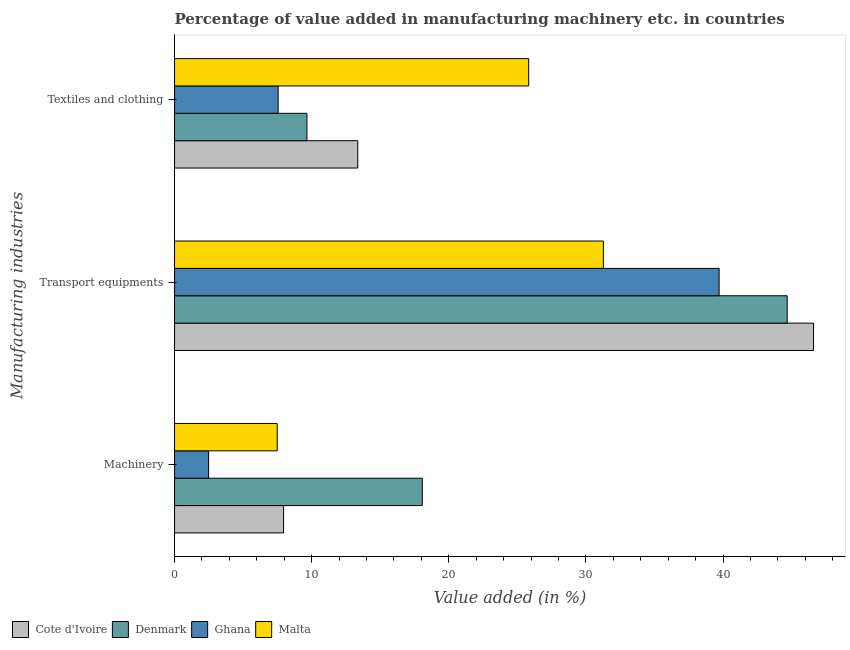How many different coloured bars are there?
Give a very brief answer. 4. How many bars are there on the 2nd tick from the top?
Give a very brief answer. 4. What is the label of the 2nd group of bars from the top?
Provide a short and direct response. Transport equipments. What is the value added in manufacturing machinery in Malta?
Offer a very short reply. 7.49. Across all countries, what is the maximum value added in manufacturing textile and clothing?
Provide a short and direct response. 25.83. Across all countries, what is the minimum value added in manufacturing textile and clothing?
Give a very brief answer. 7.55. In which country was the value added in manufacturing machinery maximum?
Provide a succinct answer. Denmark. In which country was the value added in manufacturing textile and clothing minimum?
Keep it short and to the point. Ghana. What is the total value added in manufacturing textile and clothing in the graph?
Your answer should be compact. 56.4. What is the difference between the value added in manufacturing textile and clothing in Malta and that in Cote d'Ivoire?
Ensure brevity in your answer.  12.47. What is the difference between the value added in manufacturing machinery in Denmark and the value added in manufacturing textile and clothing in Ghana?
Offer a terse response. 10.51. What is the average value added in manufacturing textile and clothing per country?
Provide a short and direct response. 14.1. What is the difference between the value added in manufacturing transport equipments and value added in manufacturing machinery in Malta?
Make the answer very short. 23.79. In how many countries, is the value added in manufacturing machinery greater than 14 %?
Your answer should be very brief. 1. What is the ratio of the value added in manufacturing textile and clothing in Malta to that in Cote d'Ivoire?
Your answer should be very brief. 1.93. Is the difference between the value added in manufacturing transport equipments in Malta and Ghana greater than the difference between the value added in manufacturing machinery in Malta and Ghana?
Give a very brief answer. No. What is the difference between the highest and the second highest value added in manufacturing machinery?
Give a very brief answer. 10.12. What is the difference between the highest and the lowest value added in manufacturing textile and clothing?
Your answer should be compact. 18.27. Is the sum of the value added in manufacturing machinery in Malta and Denmark greater than the maximum value added in manufacturing transport equipments across all countries?
Your answer should be very brief. No. What does the 1st bar from the top in Textiles and clothing represents?
Ensure brevity in your answer.  Malta. What does the 1st bar from the bottom in Machinery represents?
Offer a terse response. Cote d'Ivoire. How many countries are there in the graph?
Give a very brief answer. 4. What is the difference between two consecutive major ticks on the X-axis?
Ensure brevity in your answer.  10. Are the values on the major ticks of X-axis written in scientific E-notation?
Provide a short and direct response. No. Does the graph contain any zero values?
Make the answer very short. No. How many legend labels are there?
Offer a very short reply. 4. How are the legend labels stacked?
Your response must be concise. Horizontal. What is the title of the graph?
Provide a short and direct response. Percentage of value added in manufacturing machinery etc. in countries. Does "Lithuania" appear as one of the legend labels in the graph?
Make the answer very short. No. What is the label or title of the X-axis?
Provide a short and direct response. Value added (in %). What is the label or title of the Y-axis?
Your answer should be compact. Manufacturing industries. What is the Value added (in %) in Cote d'Ivoire in Machinery?
Give a very brief answer. 7.95. What is the Value added (in %) of Denmark in Machinery?
Make the answer very short. 18.07. What is the Value added (in %) in Ghana in Machinery?
Offer a very short reply. 2.48. What is the Value added (in %) in Malta in Machinery?
Offer a terse response. 7.49. What is the Value added (in %) of Cote d'Ivoire in Transport equipments?
Offer a terse response. 46.6. What is the Value added (in %) in Denmark in Transport equipments?
Ensure brevity in your answer.  44.68. What is the Value added (in %) in Ghana in Transport equipments?
Give a very brief answer. 39.71. What is the Value added (in %) in Malta in Transport equipments?
Offer a very short reply. 31.27. What is the Value added (in %) of Cote d'Ivoire in Textiles and clothing?
Your response must be concise. 13.36. What is the Value added (in %) in Denmark in Textiles and clothing?
Your answer should be compact. 9.65. What is the Value added (in %) of Ghana in Textiles and clothing?
Your answer should be compact. 7.55. What is the Value added (in %) in Malta in Textiles and clothing?
Provide a short and direct response. 25.83. Across all Manufacturing industries, what is the maximum Value added (in %) of Cote d'Ivoire?
Make the answer very short. 46.6. Across all Manufacturing industries, what is the maximum Value added (in %) in Denmark?
Give a very brief answer. 44.68. Across all Manufacturing industries, what is the maximum Value added (in %) of Ghana?
Provide a short and direct response. 39.71. Across all Manufacturing industries, what is the maximum Value added (in %) of Malta?
Your answer should be compact. 31.27. Across all Manufacturing industries, what is the minimum Value added (in %) in Cote d'Ivoire?
Your response must be concise. 7.95. Across all Manufacturing industries, what is the minimum Value added (in %) of Denmark?
Your response must be concise. 9.65. Across all Manufacturing industries, what is the minimum Value added (in %) of Ghana?
Make the answer very short. 2.48. Across all Manufacturing industries, what is the minimum Value added (in %) in Malta?
Make the answer very short. 7.49. What is the total Value added (in %) in Cote d'Ivoire in the graph?
Offer a very short reply. 67.91. What is the total Value added (in %) of Denmark in the graph?
Ensure brevity in your answer.  72.4. What is the total Value added (in %) in Ghana in the graph?
Your answer should be very brief. 49.75. What is the total Value added (in %) of Malta in the graph?
Your answer should be compact. 64.59. What is the difference between the Value added (in %) of Cote d'Ivoire in Machinery and that in Transport equipments?
Your answer should be very brief. -38.65. What is the difference between the Value added (in %) of Denmark in Machinery and that in Transport equipments?
Your response must be concise. -26.61. What is the difference between the Value added (in %) in Ghana in Machinery and that in Transport equipments?
Offer a very short reply. -37.23. What is the difference between the Value added (in %) of Malta in Machinery and that in Transport equipments?
Keep it short and to the point. -23.79. What is the difference between the Value added (in %) in Cote d'Ivoire in Machinery and that in Textiles and clothing?
Provide a short and direct response. -5.41. What is the difference between the Value added (in %) in Denmark in Machinery and that in Textiles and clothing?
Ensure brevity in your answer.  8.42. What is the difference between the Value added (in %) in Ghana in Machinery and that in Textiles and clothing?
Your answer should be compact. -5.07. What is the difference between the Value added (in %) in Malta in Machinery and that in Textiles and clothing?
Your answer should be very brief. -18.34. What is the difference between the Value added (in %) of Cote d'Ivoire in Transport equipments and that in Textiles and clothing?
Your answer should be very brief. 33.24. What is the difference between the Value added (in %) of Denmark in Transport equipments and that in Textiles and clothing?
Give a very brief answer. 35.02. What is the difference between the Value added (in %) of Ghana in Transport equipments and that in Textiles and clothing?
Your response must be concise. 32.16. What is the difference between the Value added (in %) in Malta in Transport equipments and that in Textiles and clothing?
Give a very brief answer. 5.45. What is the difference between the Value added (in %) in Cote d'Ivoire in Machinery and the Value added (in %) in Denmark in Transport equipments?
Ensure brevity in your answer.  -36.73. What is the difference between the Value added (in %) in Cote d'Ivoire in Machinery and the Value added (in %) in Ghana in Transport equipments?
Your answer should be compact. -31.76. What is the difference between the Value added (in %) of Cote d'Ivoire in Machinery and the Value added (in %) of Malta in Transport equipments?
Make the answer very short. -23.32. What is the difference between the Value added (in %) of Denmark in Machinery and the Value added (in %) of Ghana in Transport equipments?
Provide a succinct answer. -21.65. What is the difference between the Value added (in %) of Denmark in Machinery and the Value added (in %) of Malta in Transport equipments?
Ensure brevity in your answer.  -13.2. What is the difference between the Value added (in %) of Ghana in Machinery and the Value added (in %) of Malta in Transport equipments?
Your answer should be compact. -28.79. What is the difference between the Value added (in %) of Cote d'Ivoire in Machinery and the Value added (in %) of Denmark in Textiles and clothing?
Keep it short and to the point. -1.7. What is the difference between the Value added (in %) of Cote d'Ivoire in Machinery and the Value added (in %) of Ghana in Textiles and clothing?
Provide a short and direct response. 0.4. What is the difference between the Value added (in %) in Cote d'Ivoire in Machinery and the Value added (in %) in Malta in Textiles and clothing?
Your answer should be very brief. -17.88. What is the difference between the Value added (in %) in Denmark in Machinery and the Value added (in %) in Ghana in Textiles and clothing?
Your answer should be compact. 10.52. What is the difference between the Value added (in %) of Denmark in Machinery and the Value added (in %) of Malta in Textiles and clothing?
Your response must be concise. -7.76. What is the difference between the Value added (in %) of Ghana in Machinery and the Value added (in %) of Malta in Textiles and clothing?
Offer a very short reply. -23.34. What is the difference between the Value added (in %) of Cote d'Ivoire in Transport equipments and the Value added (in %) of Denmark in Textiles and clothing?
Make the answer very short. 36.95. What is the difference between the Value added (in %) of Cote d'Ivoire in Transport equipments and the Value added (in %) of Ghana in Textiles and clothing?
Keep it short and to the point. 39.05. What is the difference between the Value added (in %) of Cote d'Ivoire in Transport equipments and the Value added (in %) of Malta in Textiles and clothing?
Offer a terse response. 20.77. What is the difference between the Value added (in %) in Denmark in Transport equipments and the Value added (in %) in Ghana in Textiles and clothing?
Offer a very short reply. 37.12. What is the difference between the Value added (in %) in Denmark in Transport equipments and the Value added (in %) in Malta in Textiles and clothing?
Give a very brief answer. 18.85. What is the difference between the Value added (in %) of Ghana in Transport equipments and the Value added (in %) of Malta in Textiles and clothing?
Give a very brief answer. 13.89. What is the average Value added (in %) in Cote d'Ivoire per Manufacturing industries?
Make the answer very short. 22.64. What is the average Value added (in %) of Denmark per Manufacturing industries?
Your answer should be compact. 24.13. What is the average Value added (in %) in Ghana per Manufacturing industries?
Provide a short and direct response. 16.58. What is the average Value added (in %) in Malta per Manufacturing industries?
Your response must be concise. 21.53. What is the difference between the Value added (in %) in Cote d'Ivoire and Value added (in %) in Denmark in Machinery?
Your answer should be very brief. -10.12. What is the difference between the Value added (in %) in Cote d'Ivoire and Value added (in %) in Ghana in Machinery?
Make the answer very short. 5.47. What is the difference between the Value added (in %) of Cote d'Ivoire and Value added (in %) of Malta in Machinery?
Your response must be concise. 0.47. What is the difference between the Value added (in %) of Denmark and Value added (in %) of Ghana in Machinery?
Your answer should be compact. 15.59. What is the difference between the Value added (in %) of Denmark and Value added (in %) of Malta in Machinery?
Make the answer very short. 10.58. What is the difference between the Value added (in %) in Ghana and Value added (in %) in Malta in Machinery?
Give a very brief answer. -5. What is the difference between the Value added (in %) of Cote d'Ivoire and Value added (in %) of Denmark in Transport equipments?
Offer a terse response. 1.92. What is the difference between the Value added (in %) of Cote d'Ivoire and Value added (in %) of Ghana in Transport equipments?
Offer a terse response. 6.89. What is the difference between the Value added (in %) of Cote d'Ivoire and Value added (in %) of Malta in Transport equipments?
Make the answer very short. 15.33. What is the difference between the Value added (in %) of Denmark and Value added (in %) of Ghana in Transport equipments?
Keep it short and to the point. 4.96. What is the difference between the Value added (in %) of Denmark and Value added (in %) of Malta in Transport equipments?
Your response must be concise. 13.4. What is the difference between the Value added (in %) in Ghana and Value added (in %) in Malta in Transport equipments?
Your answer should be compact. 8.44. What is the difference between the Value added (in %) of Cote d'Ivoire and Value added (in %) of Denmark in Textiles and clothing?
Your answer should be compact. 3.71. What is the difference between the Value added (in %) in Cote d'Ivoire and Value added (in %) in Ghana in Textiles and clothing?
Offer a very short reply. 5.81. What is the difference between the Value added (in %) in Cote d'Ivoire and Value added (in %) in Malta in Textiles and clothing?
Your response must be concise. -12.47. What is the difference between the Value added (in %) in Denmark and Value added (in %) in Ghana in Textiles and clothing?
Your answer should be very brief. 2.1. What is the difference between the Value added (in %) of Denmark and Value added (in %) of Malta in Textiles and clothing?
Give a very brief answer. -16.17. What is the difference between the Value added (in %) in Ghana and Value added (in %) in Malta in Textiles and clothing?
Your answer should be very brief. -18.27. What is the ratio of the Value added (in %) of Cote d'Ivoire in Machinery to that in Transport equipments?
Offer a very short reply. 0.17. What is the ratio of the Value added (in %) in Denmark in Machinery to that in Transport equipments?
Your answer should be very brief. 0.4. What is the ratio of the Value added (in %) of Ghana in Machinery to that in Transport equipments?
Your answer should be very brief. 0.06. What is the ratio of the Value added (in %) of Malta in Machinery to that in Transport equipments?
Ensure brevity in your answer.  0.24. What is the ratio of the Value added (in %) in Cote d'Ivoire in Machinery to that in Textiles and clothing?
Offer a terse response. 0.6. What is the ratio of the Value added (in %) in Denmark in Machinery to that in Textiles and clothing?
Keep it short and to the point. 1.87. What is the ratio of the Value added (in %) of Ghana in Machinery to that in Textiles and clothing?
Ensure brevity in your answer.  0.33. What is the ratio of the Value added (in %) of Malta in Machinery to that in Textiles and clothing?
Offer a terse response. 0.29. What is the ratio of the Value added (in %) in Cote d'Ivoire in Transport equipments to that in Textiles and clothing?
Give a very brief answer. 3.49. What is the ratio of the Value added (in %) in Denmark in Transport equipments to that in Textiles and clothing?
Offer a terse response. 4.63. What is the ratio of the Value added (in %) of Ghana in Transport equipments to that in Textiles and clothing?
Your response must be concise. 5.26. What is the ratio of the Value added (in %) of Malta in Transport equipments to that in Textiles and clothing?
Give a very brief answer. 1.21. What is the difference between the highest and the second highest Value added (in %) of Cote d'Ivoire?
Your response must be concise. 33.24. What is the difference between the highest and the second highest Value added (in %) of Denmark?
Your response must be concise. 26.61. What is the difference between the highest and the second highest Value added (in %) of Ghana?
Make the answer very short. 32.16. What is the difference between the highest and the second highest Value added (in %) in Malta?
Offer a very short reply. 5.45. What is the difference between the highest and the lowest Value added (in %) of Cote d'Ivoire?
Your response must be concise. 38.65. What is the difference between the highest and the lowest Value added (in %) of Denmark?
Ensure brevity in your answer.  35.02. What is the difference between the highest and the lowest Value added (in %) of Ghana?
Your answer should be compact. 37.23. What is the difference between the highest and the lowest Value added (in %) in Malta?
Provide a short and direct response. 23.79. 